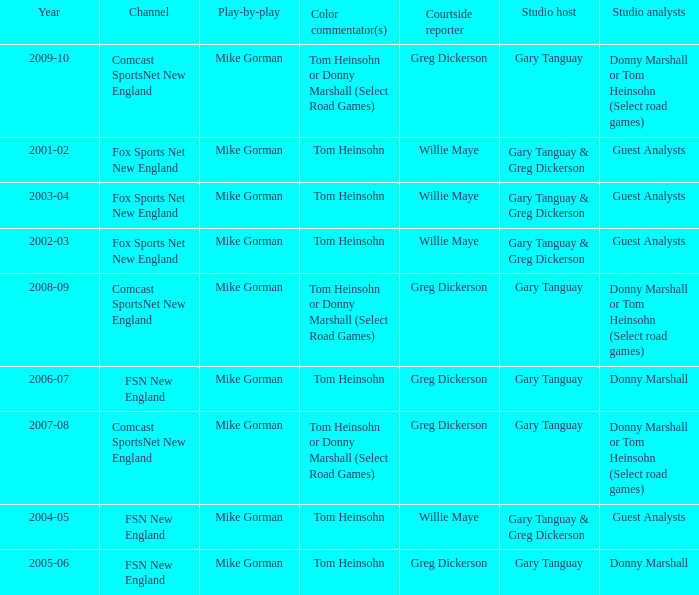How many channels were the games shown on in 2001-02? 1.0. 